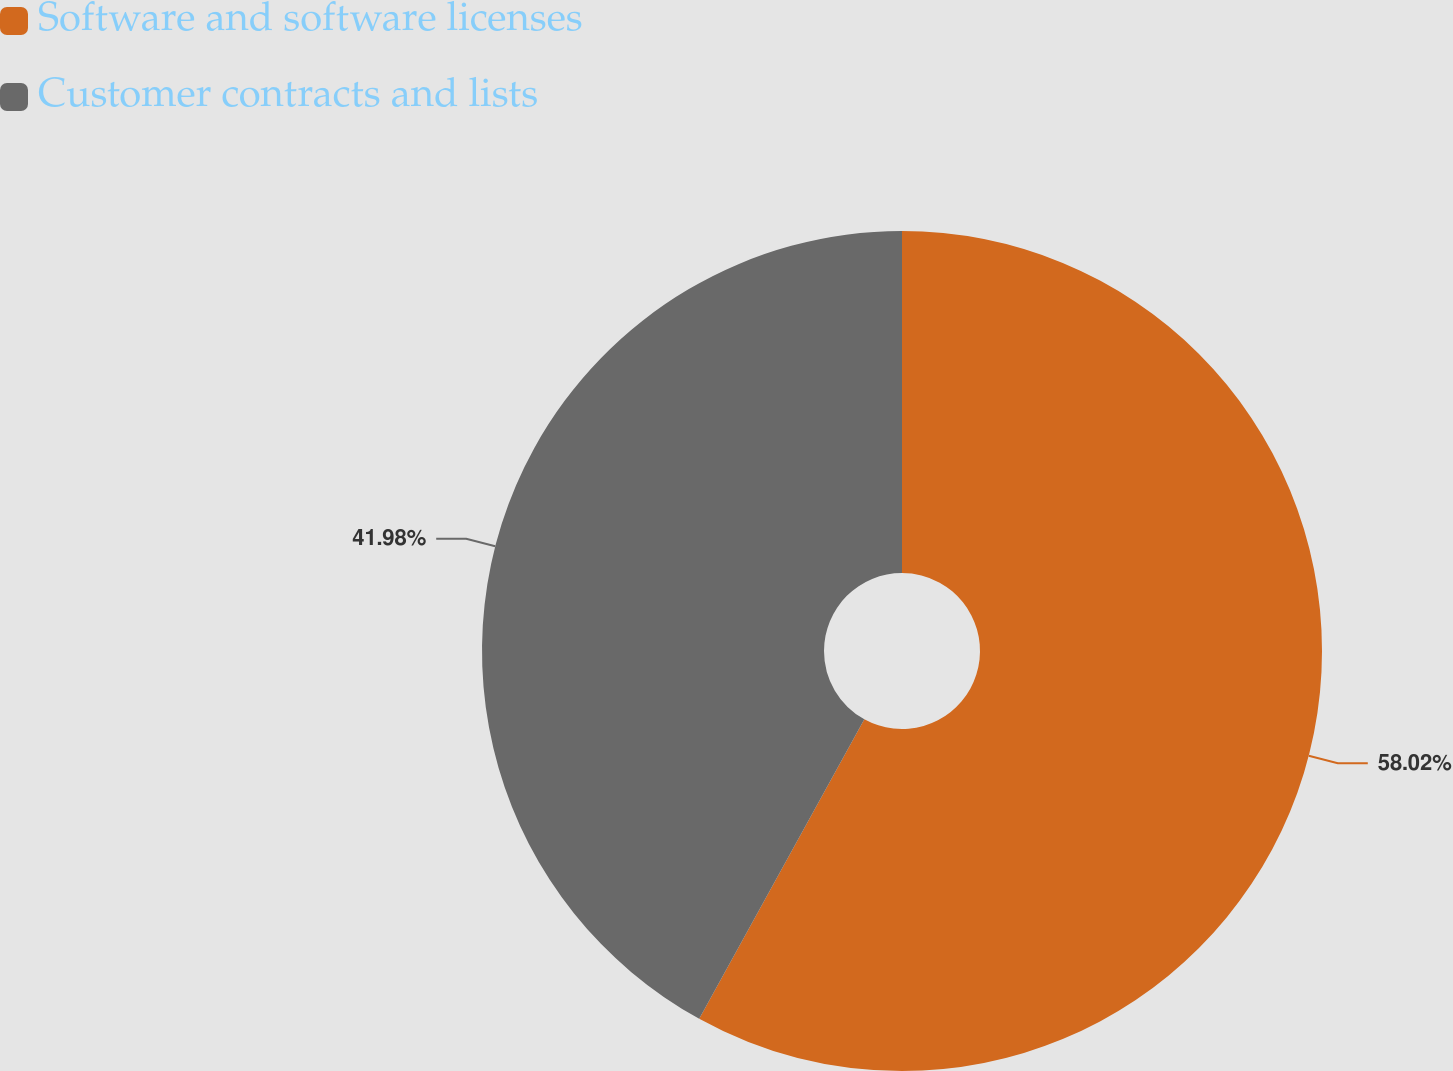Convert chart. <chart><loc_0><loc_0><loc_500><loc_500><pie_chart><fcel>Software and software licenses<fcel>Customer contracts and lists<nl><fcel>58.02%<fcel>41.98%<nl></chart> 